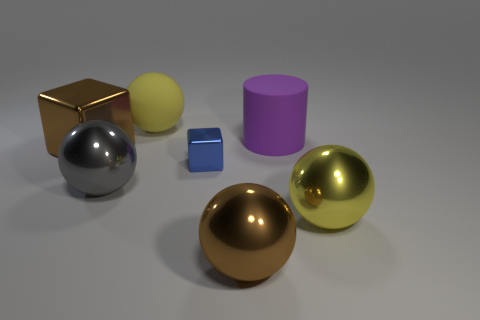Are there the same number of large metal objects that are on the left side of the rubber cylinder and big metal objects that are right of the brown metal ball?
Keep it short and to the point. No. There is a large gray object; what number of big spheres are behind it?
Make the answer very short. 1. What number of objects are large purple objects or small blue cubes?
Make the answer very short. 2. How many gray shiny objects have the same size as the purple rubber thing?
Your response must be concise. 1. What is the shape of the large brown shiny object on the left side of the brown shiny thing in front of the big brown block?
Give a very brief answer. Cube. Are there fewer gray objects than tiny green matte spheres?
Offer a terse response. No. What color is the metallic block on the left side of the blue metal cube?
Provide a succinct answer. Brown. There is a big thing that is right of the brown sphere and behind the tiny metallic block; what is its material?
Ensure brevity in your answer.  Rubber. There is a big brown object that is made of the same material as the large brown ball; what is its shape?
Offer a terse response. Cube. What number of blue metallic cubes are to the right of the brown metallic object that is behind the large gray metal thing?
Keep it short and to the point. 1. 